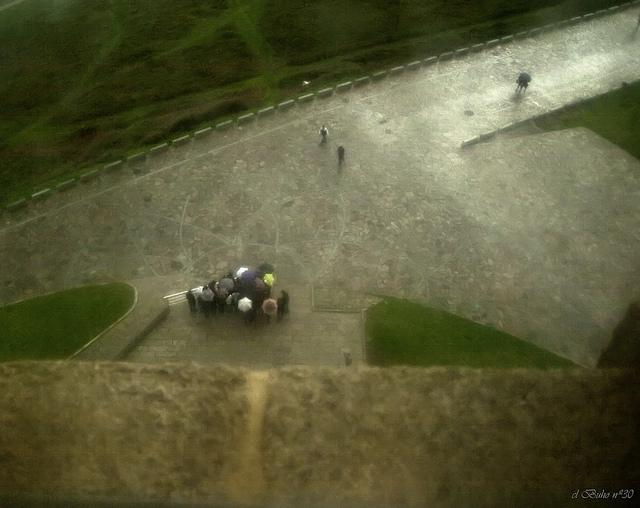What are the objects held in the small group of people at the mouth of this road? Please explain your reasoning. umbrellas. The object is an umbrella. 